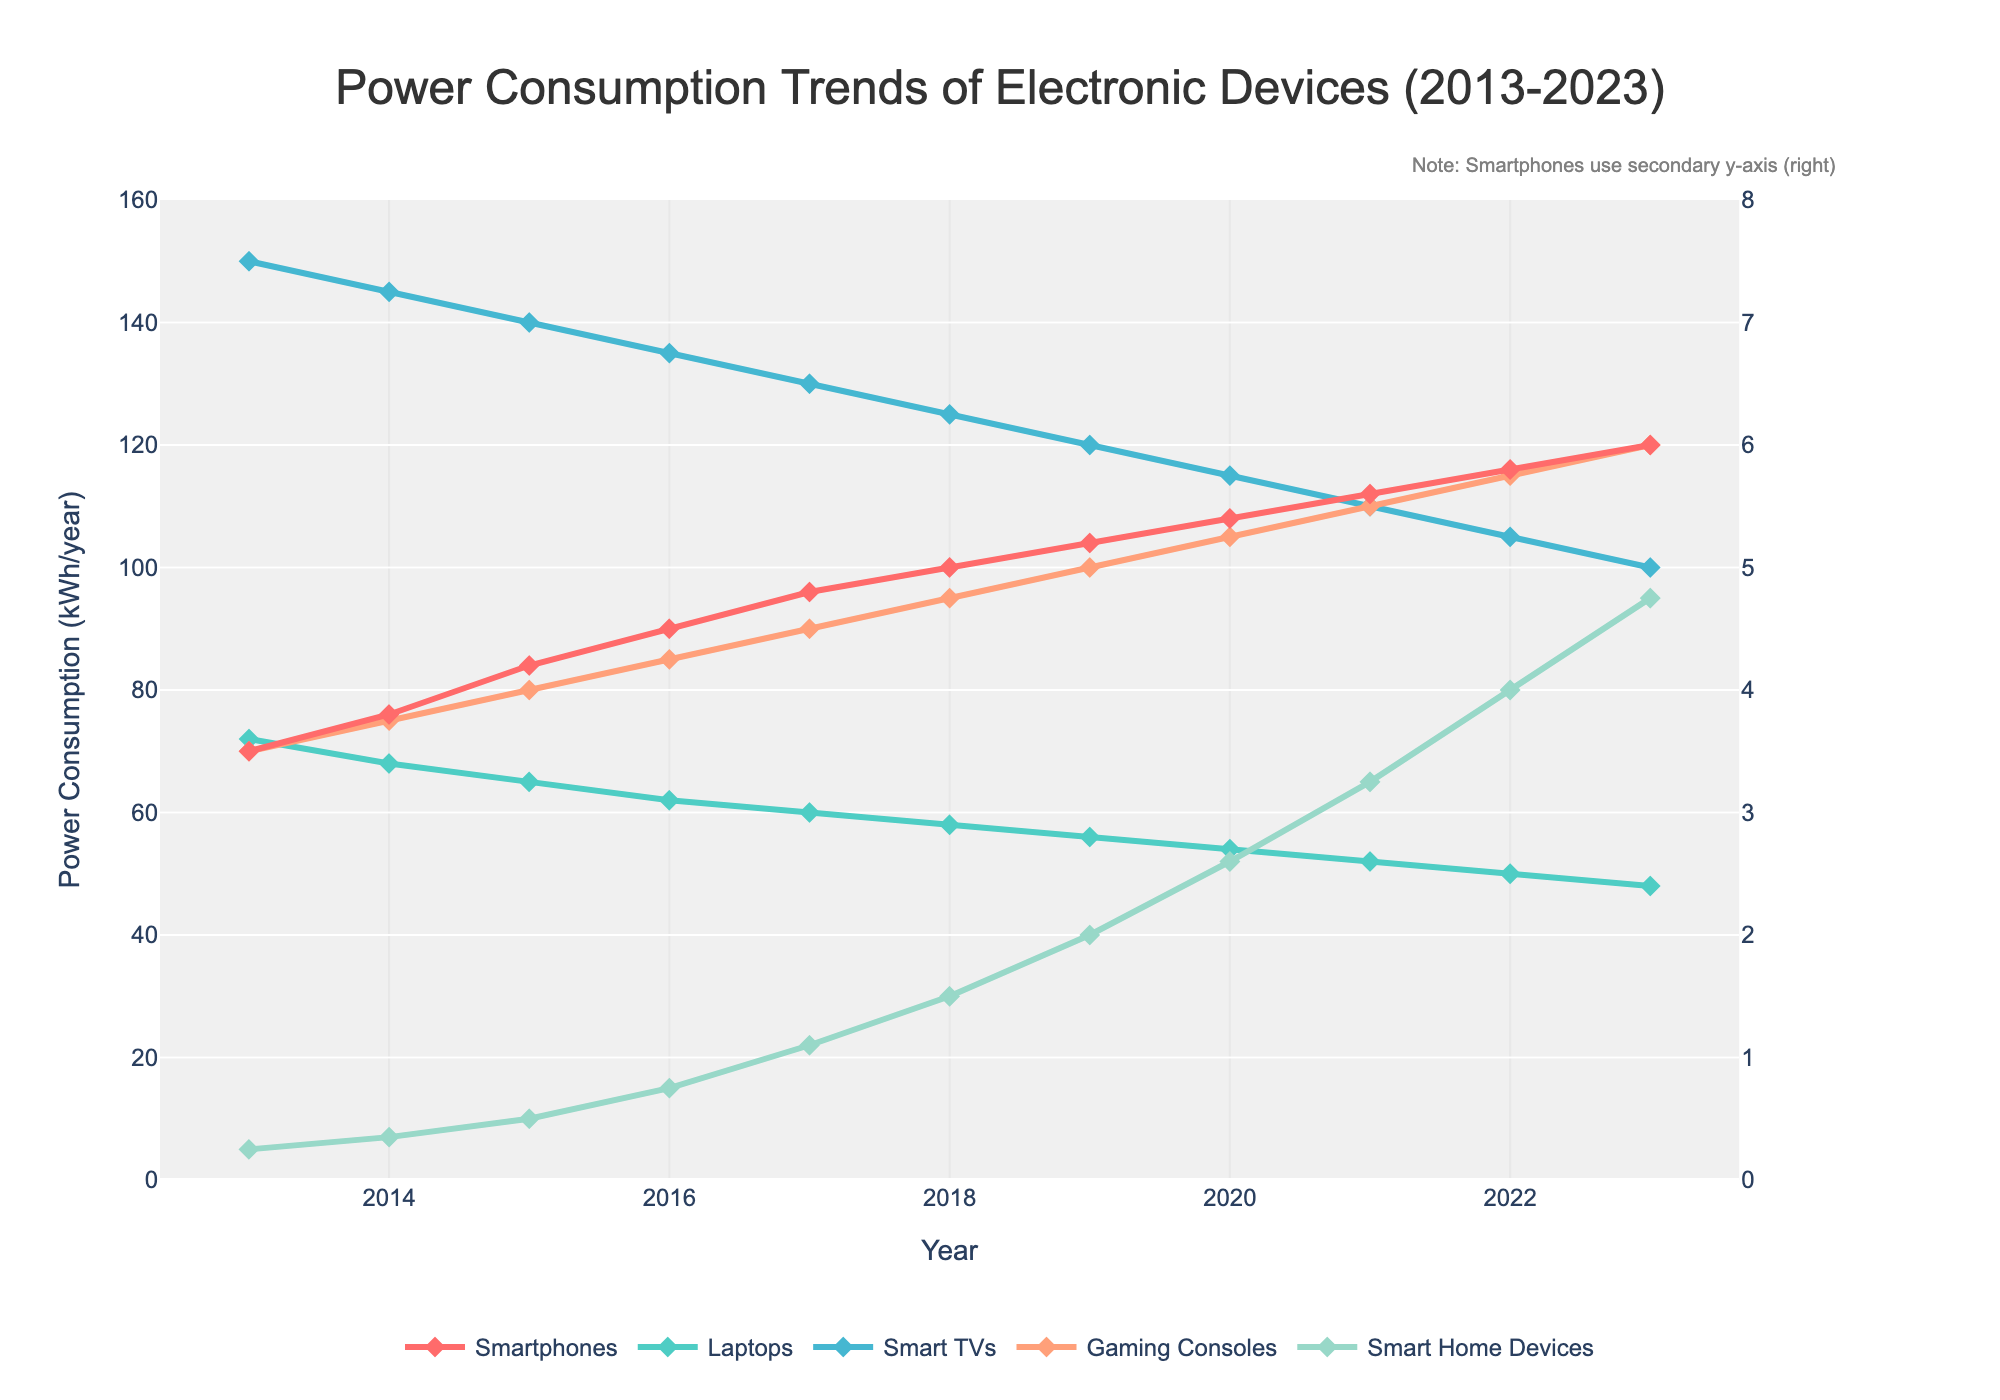What is the trend in power consumption for Smart Home Devices from 2013 to 2023? To determine the trend for Smart Home Devices, observe the line corresponding to Smart Home Devices. Note that the power consumption increases each year from 5 kWh/year in 2013 to 95 kWh/year in 2023.
Answer: Increasing Between Laptops and Gaming Consoles, which device consumed more power in 2017? Check the values for both Laptops and Gaming Consoles in the year 2017. Laptops consumed 60 kWh/year while Gaming Consoles consumed 90 kWh/year.
Answer: Gaming Consoles How much did the power consumption for Smartphones and Smart TVs combined change from 2020 to 2023? For 2020: Smartphones consumed 5.4 kWh/year, and Smart TVs consumed 115 kWh/year. Combining these is 120.4 kWh/year. For 2023: Smartphones consumed 6.0 kWh/year, and Smart TVs consumed 100 kWh/year, totaling 106 kWh/year. The change is 120.4 - 106 = 14.4 kWh/year.
Answer: 14.4 kWh/year decrease What year did the power consumption of Laptops first fall below 60 kWh/year? Observe the line for Laptops and identify the first year their consumption dips below 60 kWh/year. In 2018, the consumption was 58 kWh/year.
Answer: 2018 Which device had the sharpest increase in power consumption across the decade? Identify which device's line has the steepest slope from 2013 to 2023. Smart Home Devices went from 5 kWh/year to 95 kWh/year, the sharpest rise (90 kWh/year).
Answer: Smart Home Devices What was the approximate average power consumption of Smart TVs between 2015 and 2020? Sum the yearly values of Smart TVs from 2015 to 2020: (140 + 135 + 130 + 125 + 120 + 115) = 765 kWh/year. There are 6 years, so the average is 765/6 ≈ 127.5 kWh/year.
Answer: Approximately 127.5 kWh/year How does the power consumption of Smartphones in 2013 compare to Smart Home Devices in 2019? The power consumption for Smartphones in 2013 is 3.5 kWh/year. For Smart Home Devices, it is 40 kWh/year in 2019. Comparatively, Smart Home Devices have a higher consumption.
Answer: Smart Home Devices have higher consumption What is the percentage increase in power consumption for Smartphones from 2013 to 2023? The consumption increased from 3.5 kWh/year in 2013 to 6.0 kWh/year in 2023. The increase is 6.0 - 3.5 = 2.5 kWh/year. The percentage increase is (2.5/3.5) * 100 ≈ 71.4%.
Answer: Approximately 71.4% Which device's power consumption shows a steady decline, and what was its consumption in 2023? Observe the lines and identify the one showing a steady decline. The line for Laptops shows a continuous decrease, and the consumption in 2023 is 48 kWh/year.
Answer: Laptops at 48 kWh/year 